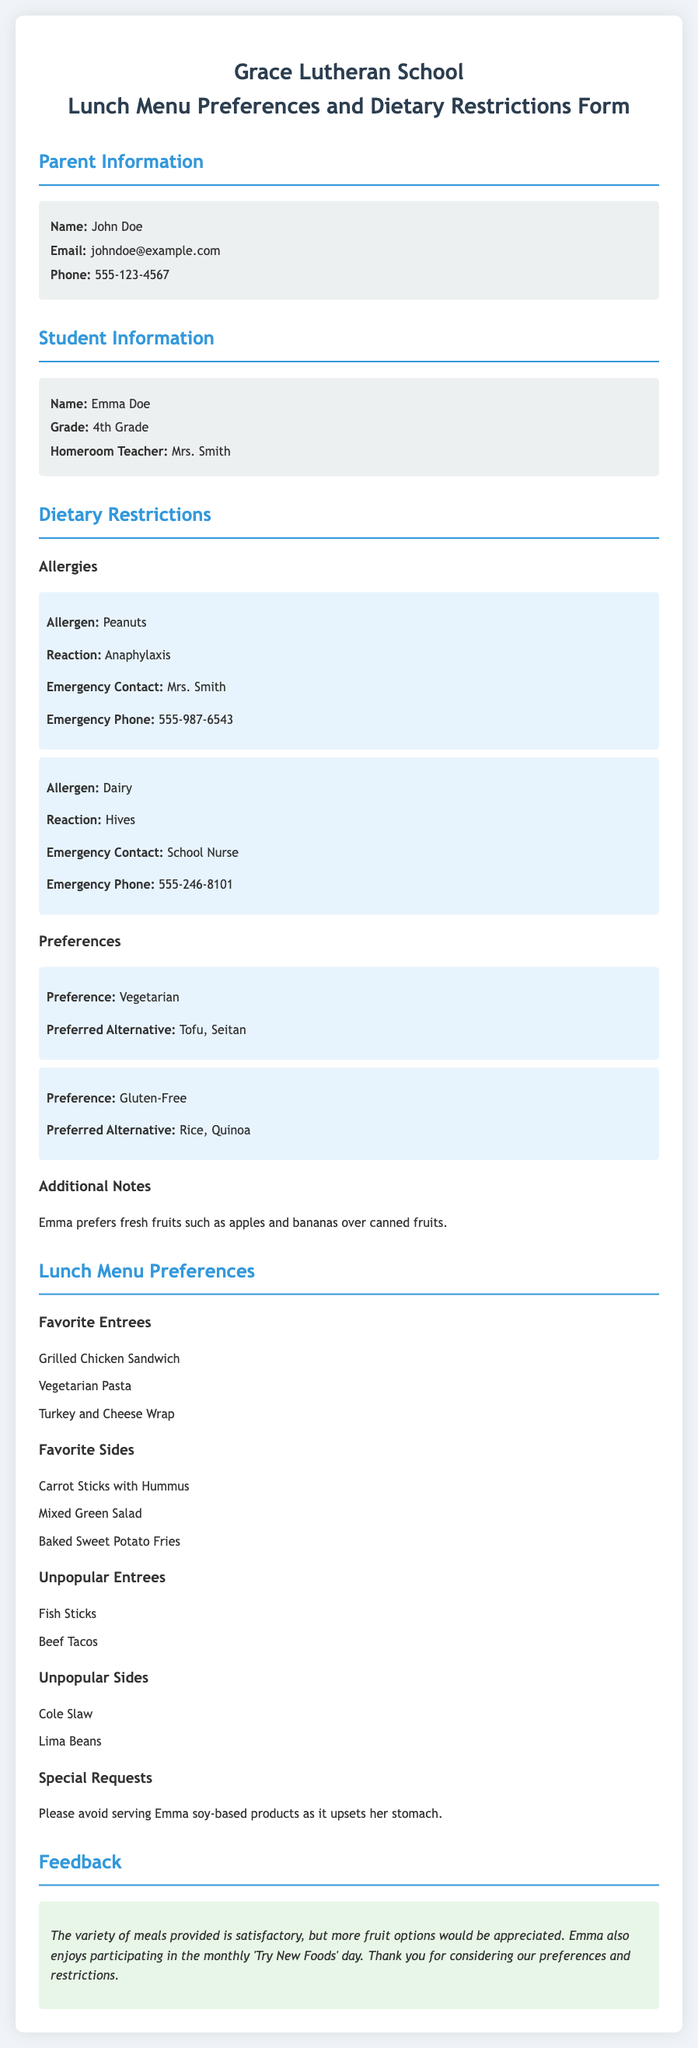What is the parent's name? The parent's name is listed in the Parent Information section of the document.
Answer: John Doe What allergies does Emma have? The allergies are detailed under the Dietary Restrictions section, listing specific allergens.
Answer: Peanuts, Dairy What is Emma's grade? The grade is mentioned in the Student Information section.
Answer: 4th Grade Who should be contacted in case of an allergic reaction to dairy? This information is provided as the emergency contact for dairy allergy in the document.
Answer: School Nurse What is Emma's preferred vegetarian alternative? The preference for vegetarian food is specified, along with the preferred alternatives.
Answer: Tofu, Seitan Which entrée is mentioned as unpopular? This information can be found in the Lunch Menu Preferences section, specifically under Unpopular Entrees.
Answer: Fish Sticks What additional note is provided about Emma's fruit preference? The note mentions Emma's preferences regarding fruits in the Additional Notes section.
Answer: Fresh fruits What special request is made regarding Emma's food? The document specifies a special request related to food that should be avoided.
Answer: Avoid serving soy-based products How does the parent feel about the variety of meals provided? The parent's feedback is summarized regarding the meal variety in the Feedback section.
Answer: Satisfactory 